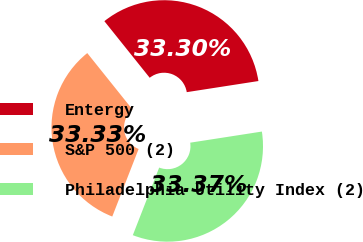<chart> <loc_0><loc_0><loc_500><loc_500><pie_chart><fcel>Entergy<fcel>S&P 500 (2)<fcel>Philadelphia Utility Index (2)<nl><fcel>33.3%<fcel>33.33%<fcel>33.37%<nl></chart> 